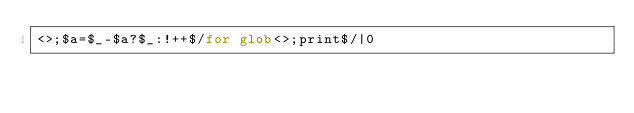Convert code to text. <code><loc_0><loc_0><loc_500><loc_500><_Perl_><>;$a=$_-$a?$_:!++$/for glob<>;print$/|0</code> 